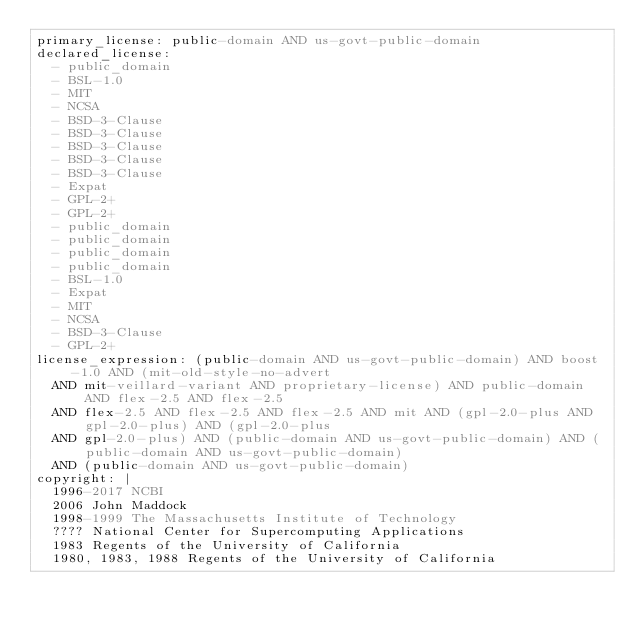Convert code to text. <code><loc_0><loc_0><loc_500><loc_500><_YAML_>primary_license: public-domain AND us-govt-public-domain
declared_license:
  - public_domain
  - BSL-1.0
  - MIT
  - NCSA
  - BSD-3-Clause
  - BSD-3-Clause
  - BSD-3-Clause
  - BSD-3-Clause
  - BSD-3-Clause
  - Expat
  - GPL-2+
  - GPL-2+
  - public_domain
  - public_domain
  - public_domain
  - public_domain
  - BSL-1.0
  - Expat
  - MIT
  - NCSA
  - BSD-3-Clause
  - GPL-2+
license_expression: (public-domain AND us-govt-public-domain) AND boost-1.0 AND (mit-old-style-no-advert
  AND mit-veillard-variant AND proprietary-license) AND public-domain AND flex-2.5 AND flex-2.5
  AND flex-2.5 AND flex-2.5 AND flex-2.5 AND mit AND (gpl-2.0-plus AND gpl-2.0-plus) AND (gpl-2.0-plus
  AND gpl-2.0-plus) AND (public-domain AND us-govt-public-domain) AND (public-domain AND us-govt-public-domain)
  AND (public-domain AND us-govt-public-domain)
copyright: |
  1996-2017 NCBI
  2006 John Maddock
  1998-1999 The Massachusetts Institute of Technology
  ???? National Center for Supercomputing Applications
  1983 Regents of the University of California
  1980, 1983, 1988 Regents of the University of California</code> 